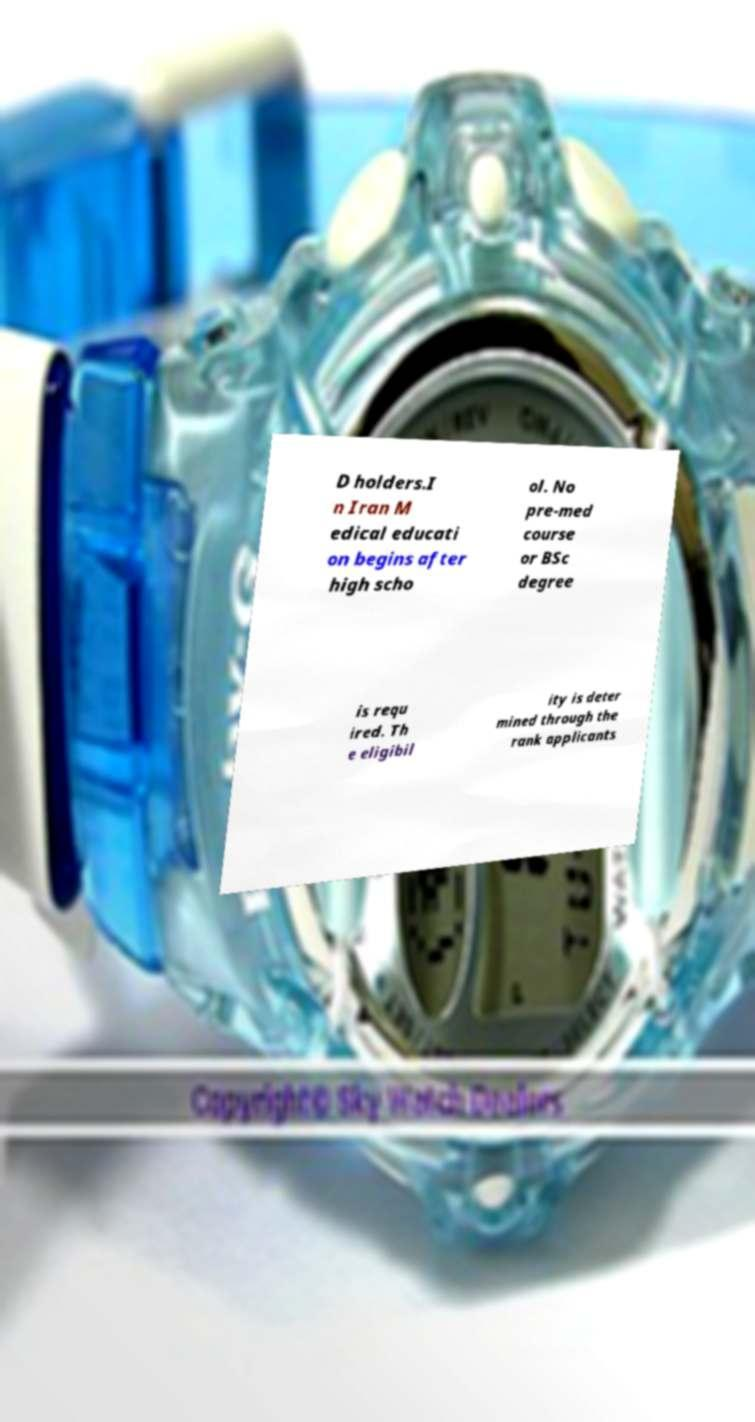Could you extract and type out the text from this image? D holders.I n Iran M edical educati on begins after high scho ol. No pre-med course or BSc degree is requ ired. Th e eligibil ity is deter mined through the rank applicants 